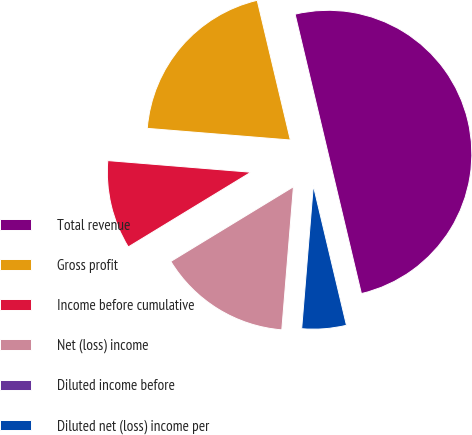<chart> <loc_0><loc_0><loc_500><loc_500><pie_chart><fcel>Total revenue<fcel>Gross profit<fcel>Income before cumulative<fcel>Net (loss) income<fcel>Diluted income before<fcel>Diluted net (loss) income per<nl><fcel>50.0%<fcel>20.0%<fcel>10.0%<fcel>15.0%<fcel>0.0%<fcel>5.0%<nl></chart> 